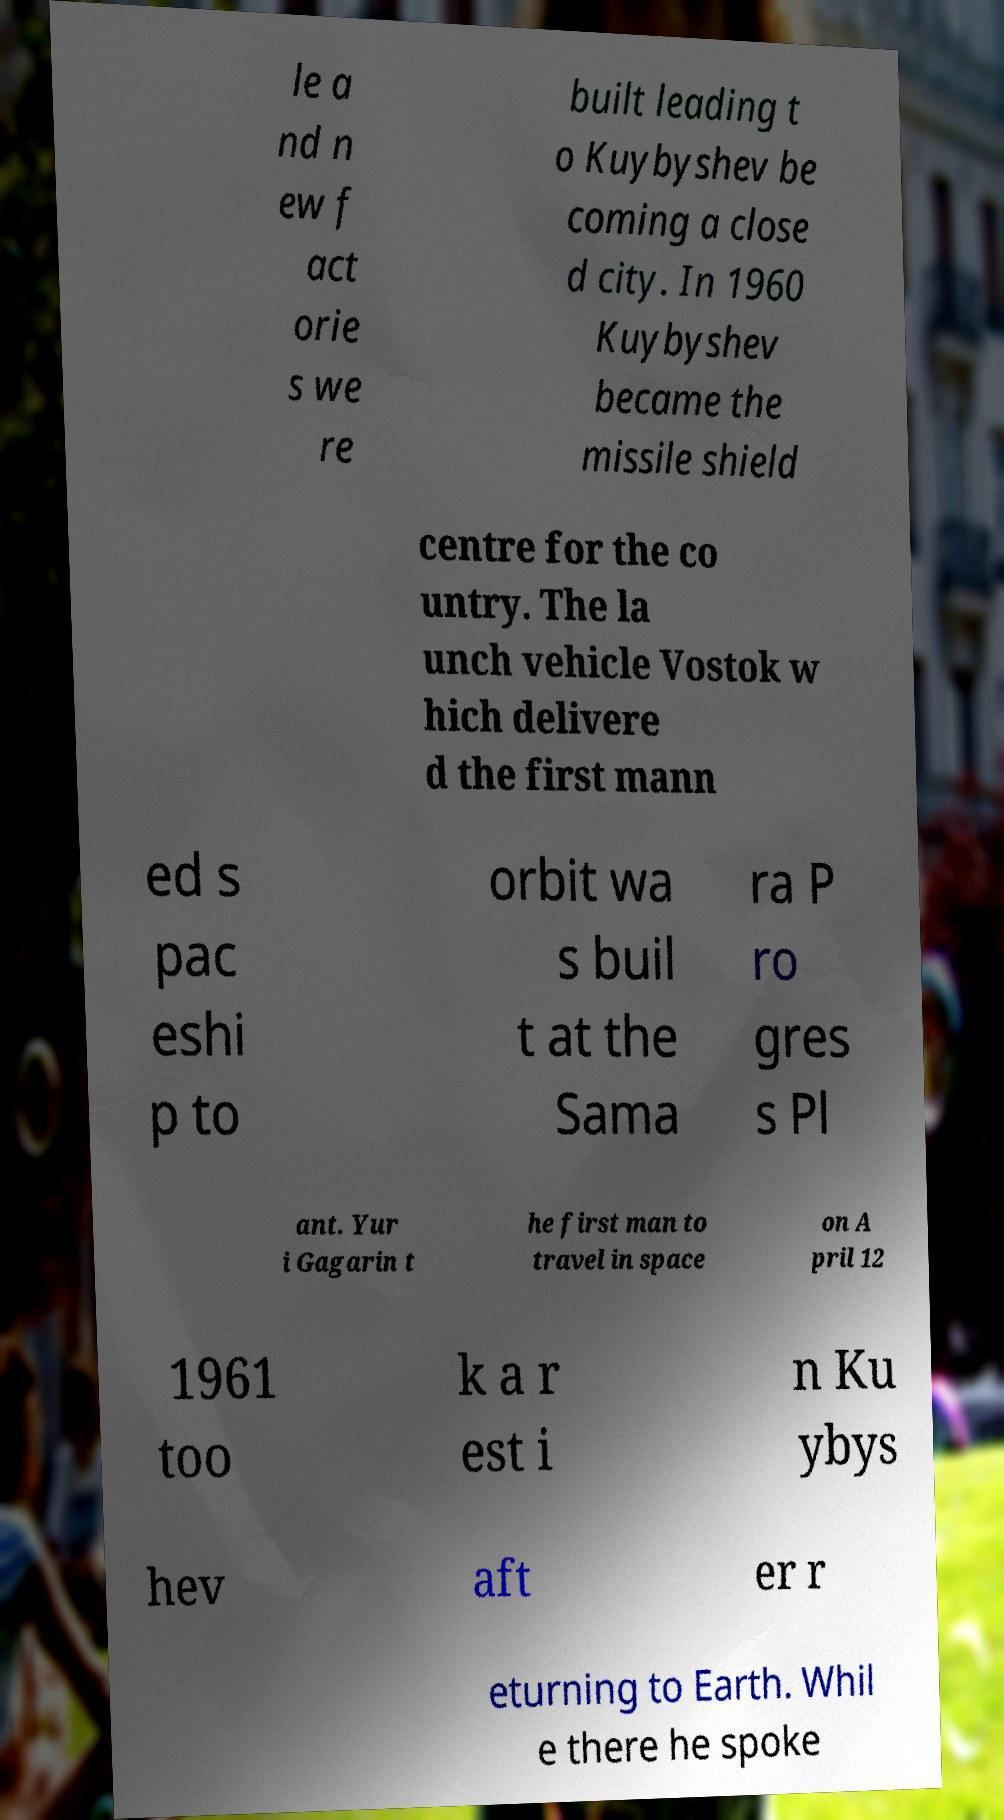What messages or text are displayed in this image? I need them in a readable, typed format. le a nd n ew f act orie s we re built leading t o Kuybyshev be coming a close d city. In 1960 Kuybyshev became the missile shield centre for the co untry. The la unch vehicle Vostok w hich delivere d the first mann ed s pac eshi p to orbit wa s buil t at the Sama ra P ro gres s Pl ant. Yur i Gagarin t he first man to travel in space on A pril 12 1961 too k a r est i n Ku ybys hev aft er r eturning to Earth. Whil e there he spoke 